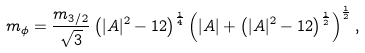Convert formula to latex. <formula><loc_0><loc_0><loc_500><loc_500>m _ { \phi } = \frac { m _ { 3 / 2 } } { \sqrt { 3 } } \left ( | A | ^ { 2 } - 1 2 \right ) ^ { \frac { 1 } { 4 } } \left ( | A | + \left ( | A | ^ { 2 } - 1 2 \right ) ^ { \frac { 1 } { 2 } } \right ) ^ { \frac { 1 } { 2 } } ,</formula> 